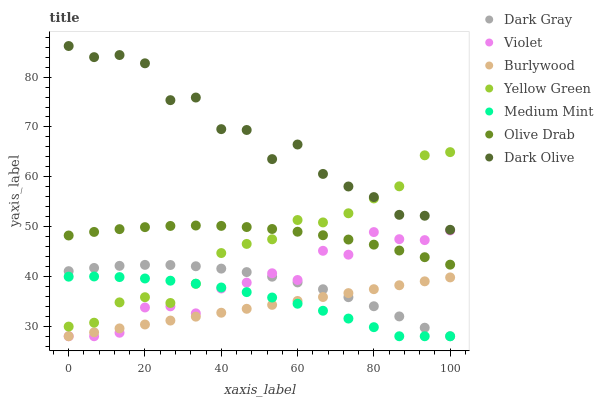Does Burlywood have the minimum area under the curve?
Answer yes or no. Yes. Does Dark Olive have the maximum area under the curve?
Answer yes or no. Yes. Does Yellow Green have the minimum area under the curve?
Answer yes or no. No. Does Yellow Green have the maximum area under the curve?
Answer yes or no. No. Is Burlywood the smoothest?
Answer yes or no. Yes. Is Dark Olive the roughest?
Answer yes or no. Yes. Is Yellow Green the smoothest?
Answer yes or no. No. Is Yellow Green the roughest?
Answer yes or no. No. Does Medium Mint have the lowest value?
Answer yes or no. Yes. Does Yellow Green have the lowest value?
Answer yes or no. No. Does Dark Olive have the highest value?
Answer yes or no. Yes. Does Yellow Green have the highest value?
Answer yes or no. No. Is Violet less than Yellow Green?
Answer yes or no. Yes. Is Dark Olive greater than Medium Mint?
Answer yes or no. Yes. Does Dark Gray intersect Medium Mint?
Answer yes or no. Yes. Is Dark Gray less than Medium Mint?
Answer yes or no. No. Is Dark Gray greater than Medium Mint?
Answer yes or no. No. Does Violet intersect Yellow Green?
Answer yes or no. No. 